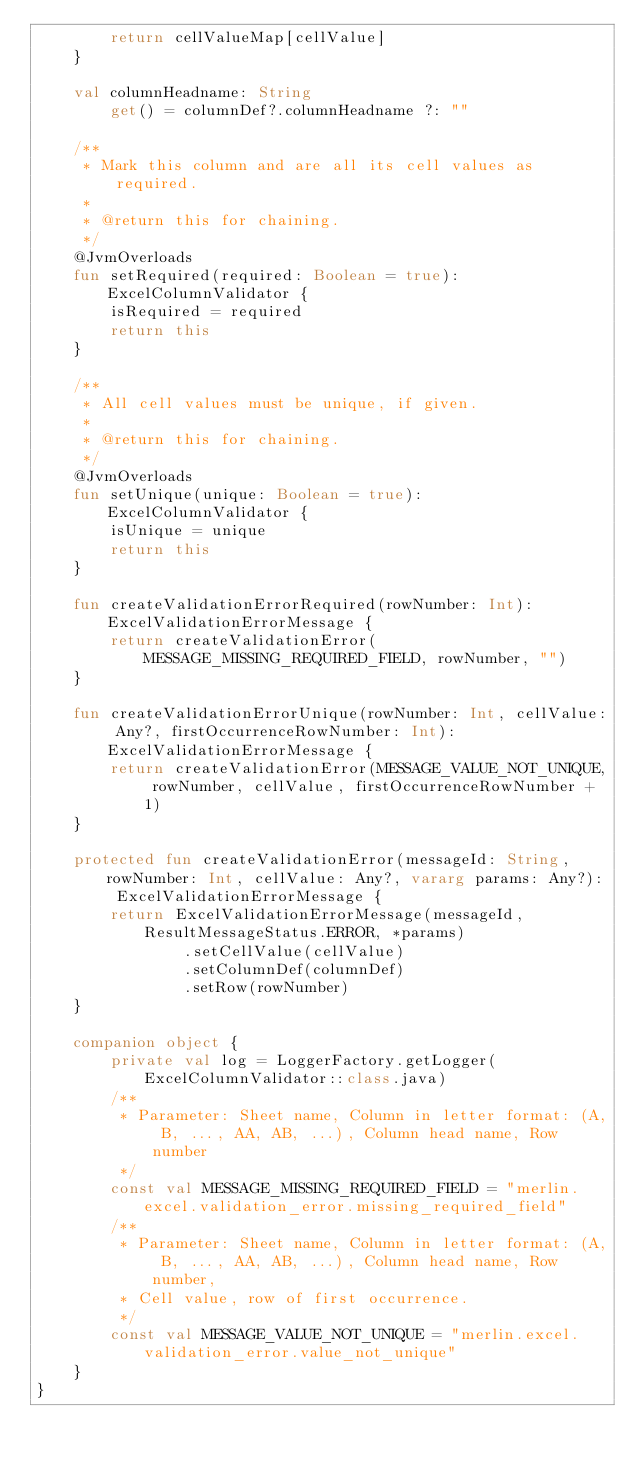Convert code to text. <code><loc_0><loc_0><loc_500><loc_500><_Kotlin_>        return cellValueMap[cellValue]
    }

    val columnHeadname: String
        get() = columnDef?.columnHeadname ?: ""

    /**
     * Mark this column and are all its cell values as required.
     *
     * @return this for chaining.
     */
    @JvmOverloads
    fun setRequired(required: Boolean = true): ExcelColumnValidator {
        isRequired = required
        return this
    }

    /**
     * All cell values must be unique, if given.
     *
     * @return this for chaining.
     */
    @JvmOverloads
    fun setUnique(unique: Boolean = true): ExcelColumnValidator {
        isUnique = unique
        return this
    }

    fun createValidationErrorRequired(rowNumber: Int): ExcelValidationErrorMessage {
        return createValidationError(MESSAGE_MISSING_REQUIRED_FIELD, rowNumber, "")
    }

    fun createValidationErrorUnique(rowNumber: Int, cellValue: Any?, firstOccurrenceRowNumber: Int): ExcelValidationErrorMessage {
        return createValidationError(MESSAGE_VALUE_NOT_UNIQUE, rowNumber, cellValue, firstOccurrenceRowNumber + 1)
    }

    protected fun createValidationError(messageId: String, rowNumber: Int, cellValue: Any?, vararg params: Any?): ExcelValidationErrorMessage {
        return ExcelValidationErrorMessage(messageId, ResultMessageStatus.ERROR, *params)
                .setCellValue(cellValue)
                .setColumnDef(columnDef)
                .setRow(rowNumber)
    }

    companion object {
        private val log = LoggerFactory.getLogger(ExcelColumnValidator::class.java)
        /**
         * Parameter: Sheet name, Column in letter format: (A, B, ..., AA, AB, ...), Column head name, Row number
         */
        const val MESSAGE_MISSING_REQUIRED_FIELD = "merlin.excel.validation_error.missing_required_field"
        /**
         * Parameter: Sheet name, Column in letter format: (A, B, ..., AA, AB, ...), Column head name, Row number,
         * Cell value, row of first occurrence.
         */
        const val MESSAGE_VALUE_NOT_UNIQUE = "merlin.excel.validation_error.value_not_unique"
    }
}
</code> 